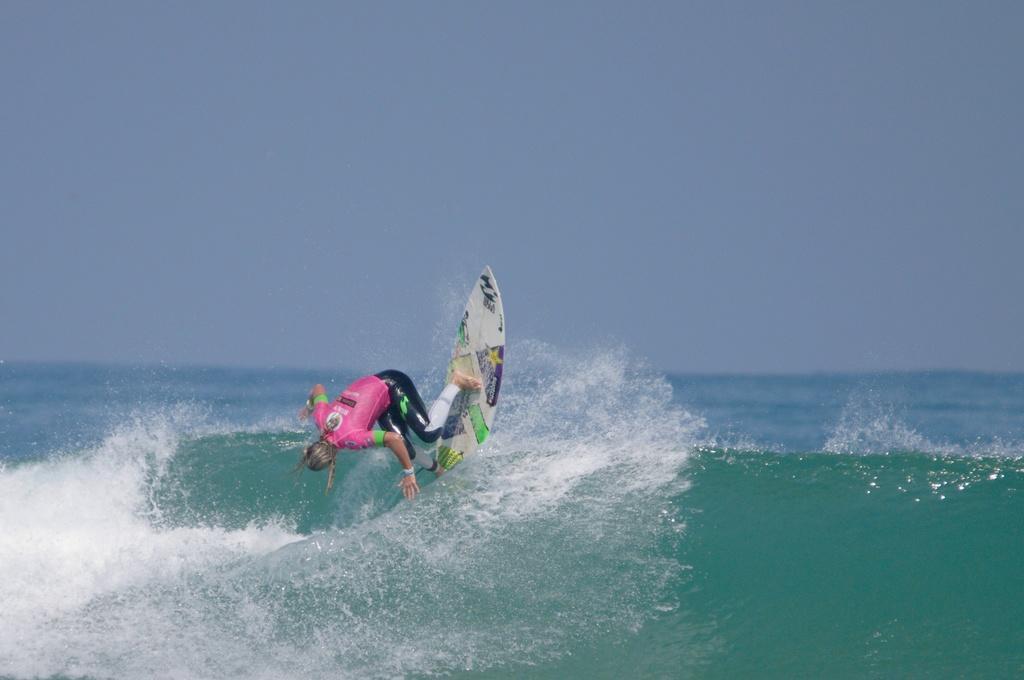How would you summarize this image in a sentence or two? In this image I can see water in the front. I can also see a person and a white colour surfing board on the water. I can see this person is wearing swimming costume and in the background I can see the sky. 